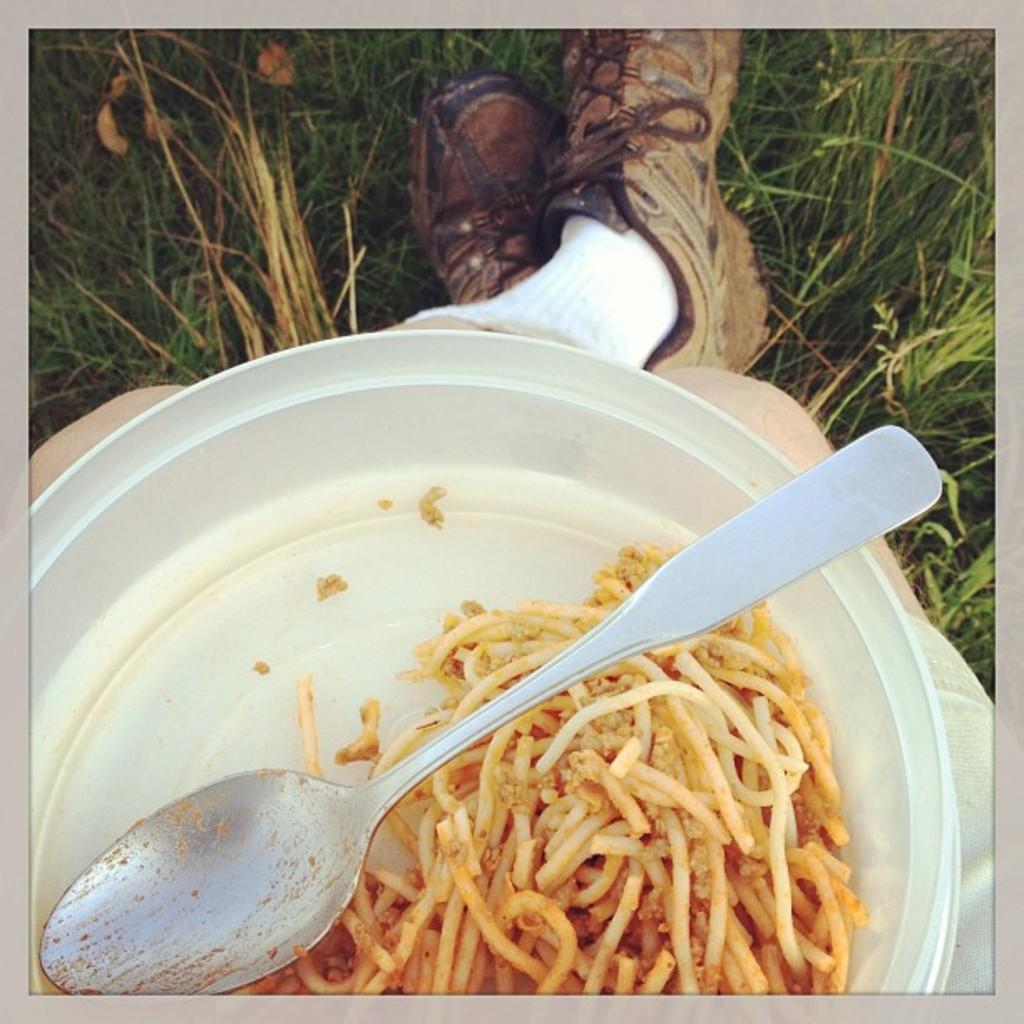Describe this image in one or two sentences. In the image in the center we can see one person sitting and holding plate. In plate,we can see spoon and noodles. In the background we can see grass. 